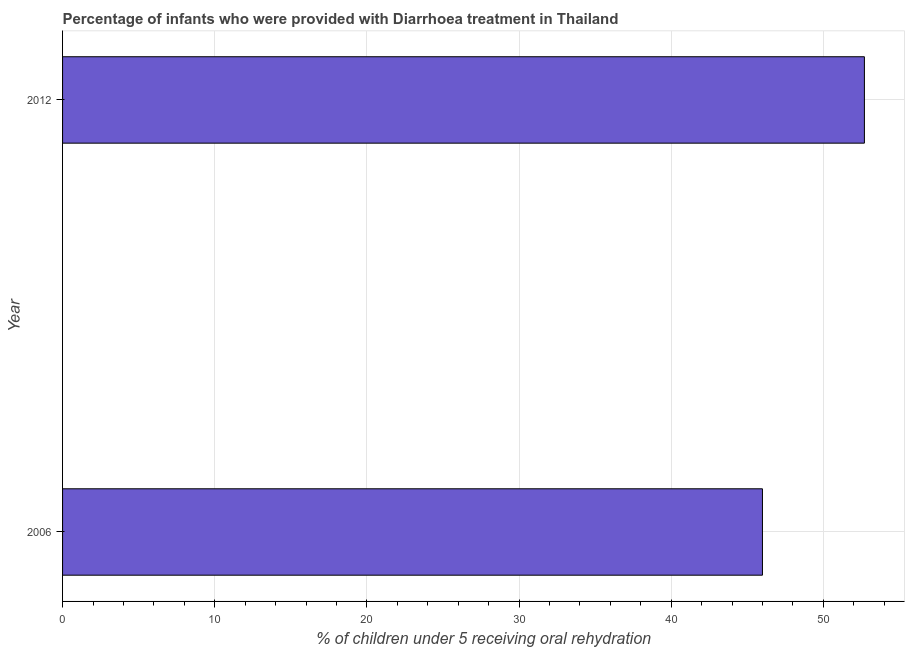Does the graph contain any zero values?
Your answer should be very brief. No. Does the graph contain grids?
Your answer should be compact. Yes. What is the title of the graph?
Give a very brief answer. Percentage of infants who were provided with Diarrhoea treatment in Thailand. What is the label or title of the X-axis?
Make the answer very short. % of children under 5 receiving oral rehydration. What is the percentage of children who were provided with treatment diarrhoea in 2006?
Make the answer very short. 46. Across all years, what is the maximum percentage of children who were provided with treatment diarrhoea?
Offer a terse response. 52.7. Across all years, what is the minimum percentage of children who were provided with treatment diarrhoea?
Offer a very short reply. 46. In which year was the percentage of children who were provided with treatment diarrhoea maximum?
Provide a succinct answer. 2012. What is the sum of the percentage of children who were provided with treatment diarrhoea?
Your answer should be very brief. 98.7. What is the average percentage of children who were provided with treatment diarrhoea per year?
Provide a succinct answer. 49.35. What is the median percentage of children who were provided with treatment diarrhoea?
Offer a very short reply. 49.35. What is the ratio of the percentage of children who were provided with treatment diarrhoea in 2006 to that in 2012?
Your response must be concise. 0.87. Is the percentage of children who were provided with treatment diarrhoea in 2006 less than that in 2012?
Offer a terse response. Yes. What is the % of children under 5 receiving oral rehydration in 2006?
Make the answer very short. 46. What is the % of children under 5 receiving oral rehydration in 2012?
Your answer should be compact. 52.7. What is the ratio of the % of children under 5 receiving oral rehydration in 2006 to that in 2012?
Ensure brevity in your answer.  0.87. 